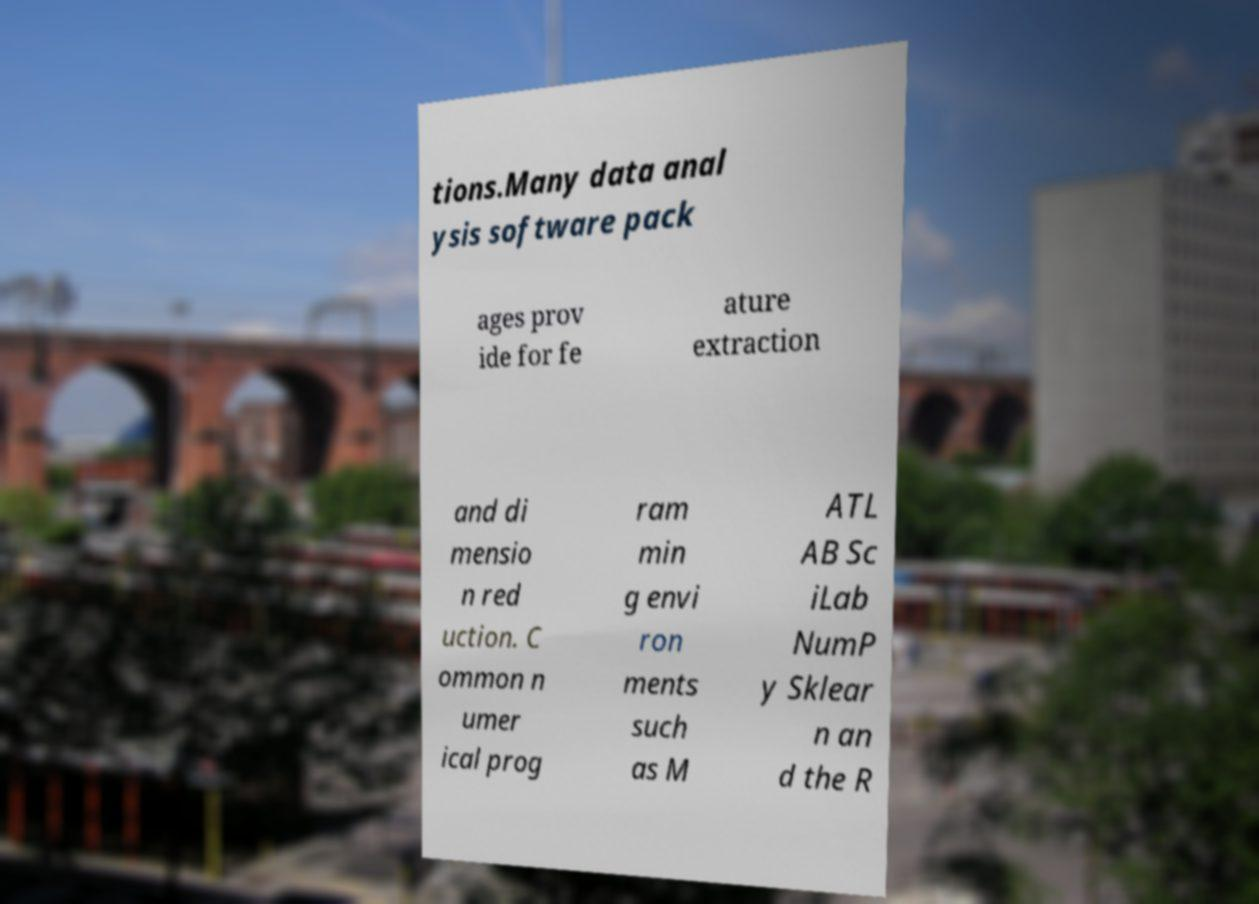Please identify and transcribe the text found in this image. tions.Many data anal ysis software pack ages prov ide for fe ature extraction and di mensio n red uction. C ommon n umer ical prog ram min g envi ron ments such as M ATL AB Sc iLab NumP y Sklear n an d the R 